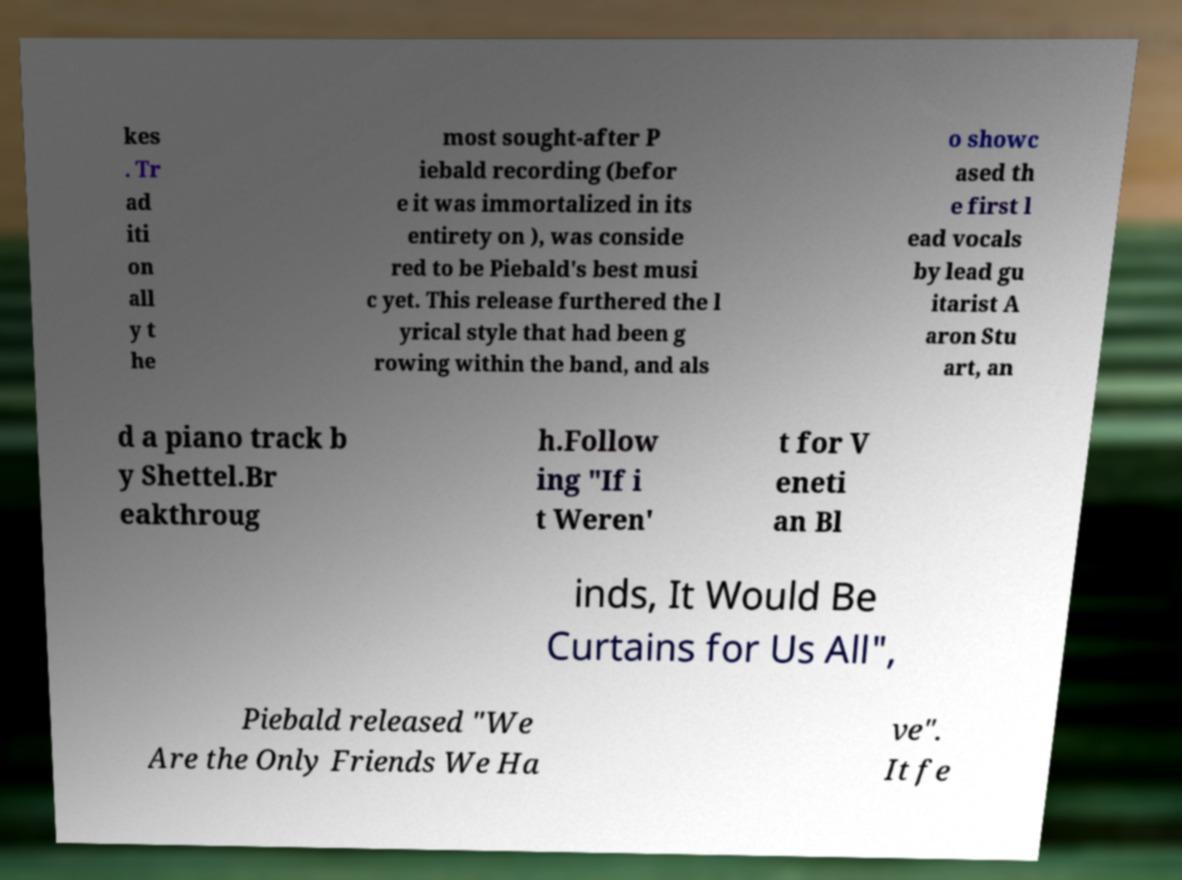For documentation purposes, I need the text within this image transcribed. Could you provide that? kes . Tr ad iti on all y t he most sought-after P iebald recording (befor e it was immortalized in its entirety on ), was conside red to be Piebald's best musi c yet. This release furthered the l yrical style that had been g rowing within the band, and als o showc ased th e first l ead vocals by lead gu itarist A aron Stu art, an d a piano track b y Shettel.Br eakthroug h.Follow ing "If i t Weren' t for V eneti an Bl inds, It Would Be Curtains for Us All", Piebald released "We Are the Only Friends We Ha ve". It fe 